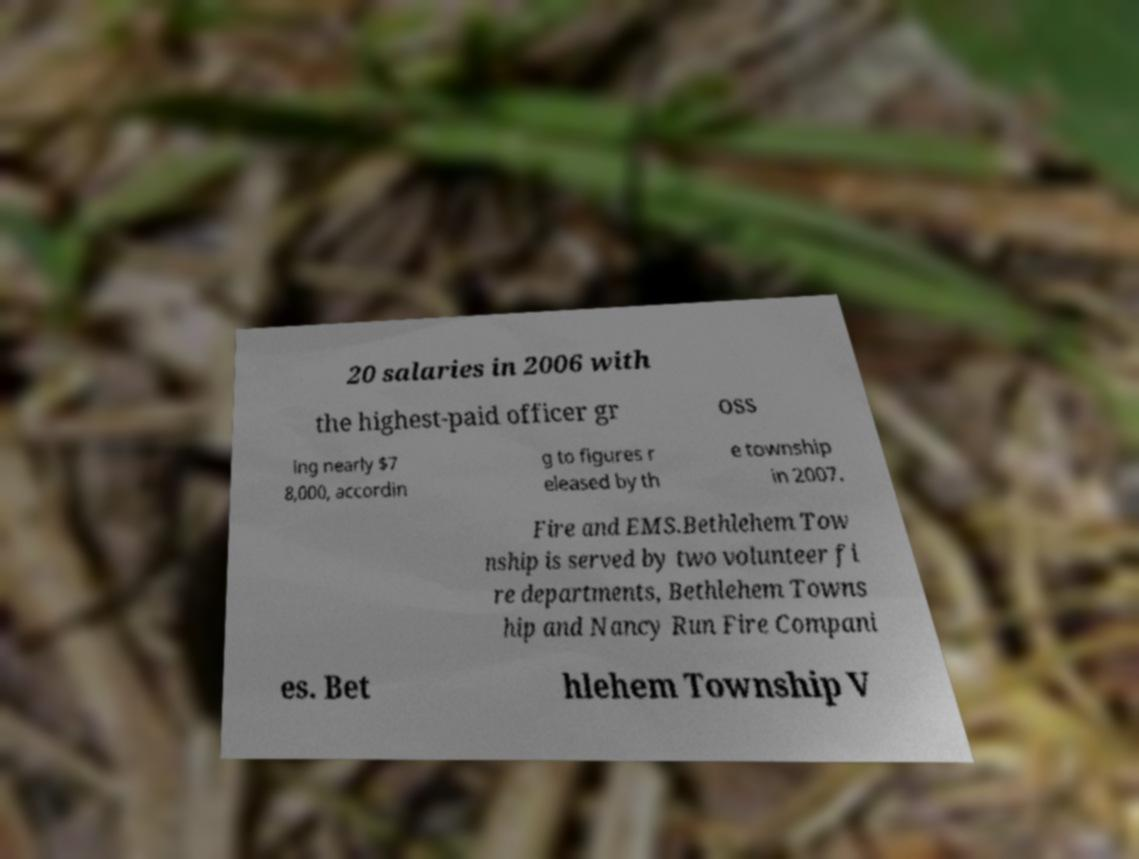What messages or text are displayed in this image? I need them in a readable, typed format. 20 salaries in 2006 with the highest-paid officer gr oss ing nearly $7 8,000, accordin g to figures r eleased by th e township in 2007. Fire and EMS.Bethlehem Tow nship is served by two volunteer fi re departments, Bethlehem Towns hip and Nancy Run Fire Compani es. Bet hlehem Township V 